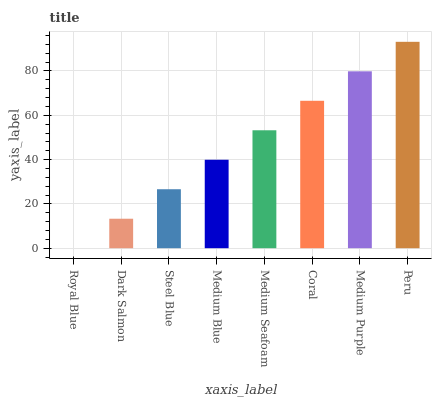Is Royal Blue the minimum?
Answer yes or no. Yes. Is Peru the maximum?
Answer yes or no. Yes. Is Dark Salmon the minimum?
Answer yes or no. No. Is Dark Salmon the maximum?
Answer yes or no. No. Is Dark Salmon greater than Royal Blue?
Answer yes or no. Yes. Is Royal Blue less than Dark Salmon?
Answer yes or no. Yes. Is Royal Blue greater than Dark Salmon?
Answer yes or no. No. Is Dark Salmon less than Royal Blue?
Answer yes or no. No. Is Medium Seafoam the high median?
Answer yes or no. Yes. Is Medium Blue the low median?
Answer yes or no. Yes. Is Dark Salmon the high median?
Answer yes or no. No. Is Royal Blue the low median?
Answer yes or no. No. 